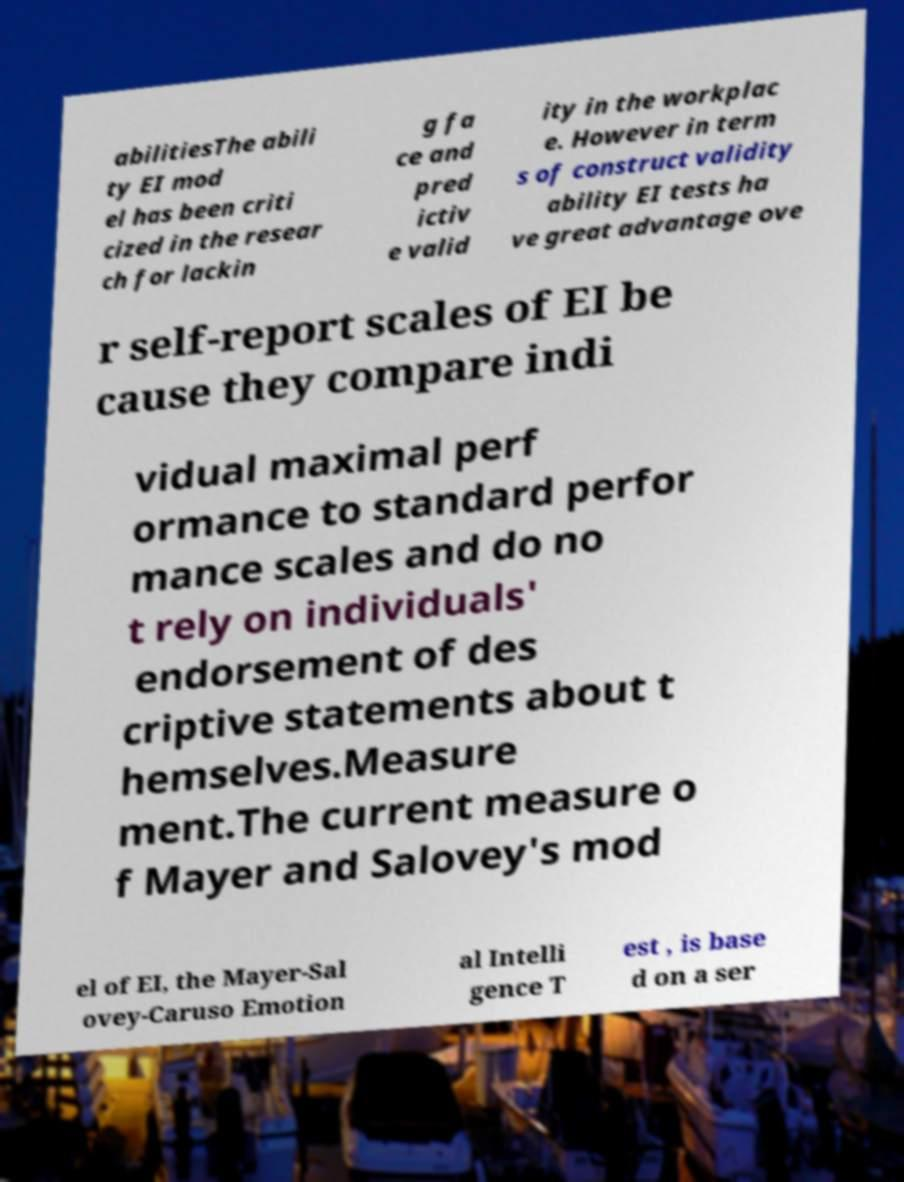Could you extract and type out the text from this image? abilitiesThe abili ty EI mod el has been criti cized in the resear ch for lackin g fa ce and pred ictiv e valid ity in the workplac e. However in term s of construct validity ability EI tests ha ve great advantage ove r self-report scales of EI be cause they compare indi vidual maximal perf ormance to standard perfor mance scales and do no t rely on individuals' endorsement of des criptive statements about t hemselves.Measure ment.The current measure o f Mayer and Salovey's mod el of EI, the Mayer-Sal ovey-Caruso Emotion al Intelli gence T est , is base d on a ser 